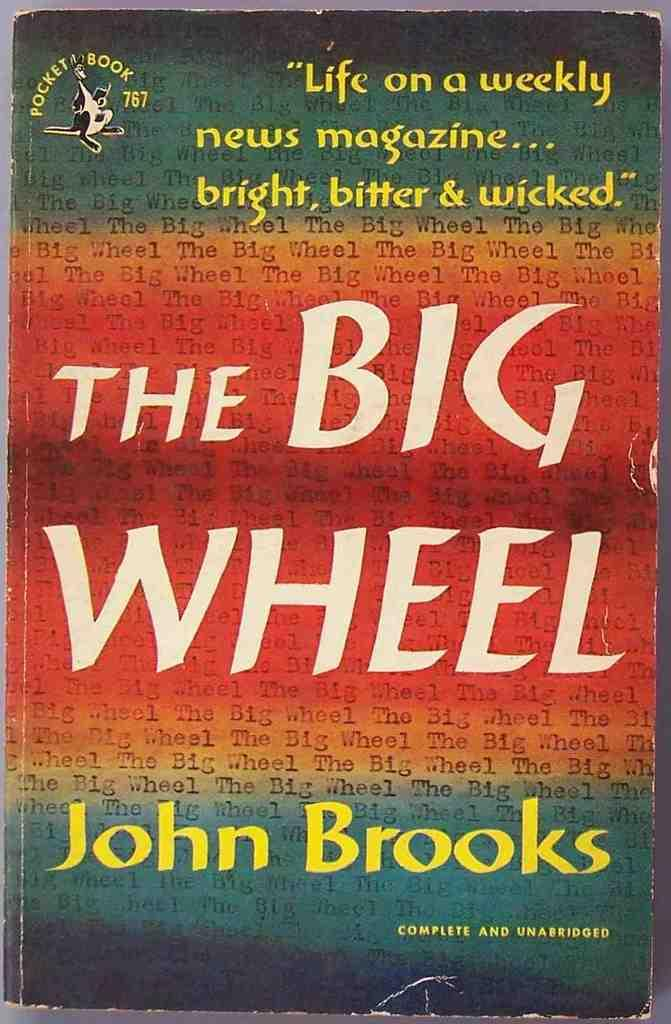<image>
Describe the image concisely. The book The Big Wheell by John Brooks complete and unabridged. 